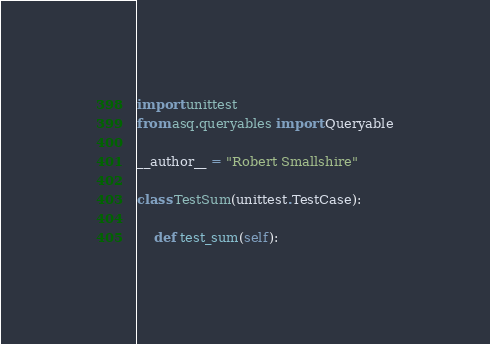Convert code to text. <code><loc_0><loc_0><loc_500><loc_500><_Python_>import unittest
from asq.queryables import Queryable

__author__ = "Robert Smallshire"

class TestSum(unittest.TestCase):

    def test_sum(self):</code> 